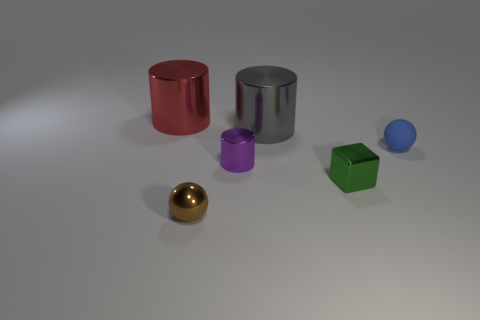Add 1 small gray blocks. How many objects exist? 7 Subtract all spheres. How many objects are left? 4 Subtract all red shiny spheres. Subtract all small brown metal spheres. How many objects are left? 5 Add 3 cubes. How many cubes are left? 4 Add 6 tiny green metal blocks. How many tiny green metal blocks exist? 7 Subtract 0 yellow cylinders. How many objects are left? 6 